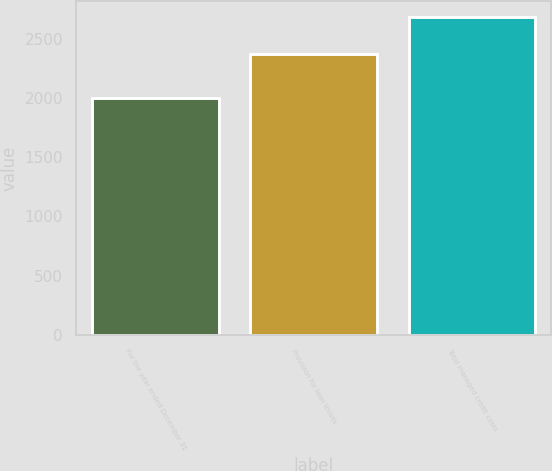Convert chart. <chart><loc_0><loc_0><loc_500><loc_500><bar_chart><fcel>For the year ended December 31<fcel>Provision for loan losses<fcel>Total managed credit costs<nl><fcel>2002<fcel>2371<fcel>2680<nl></chart> 